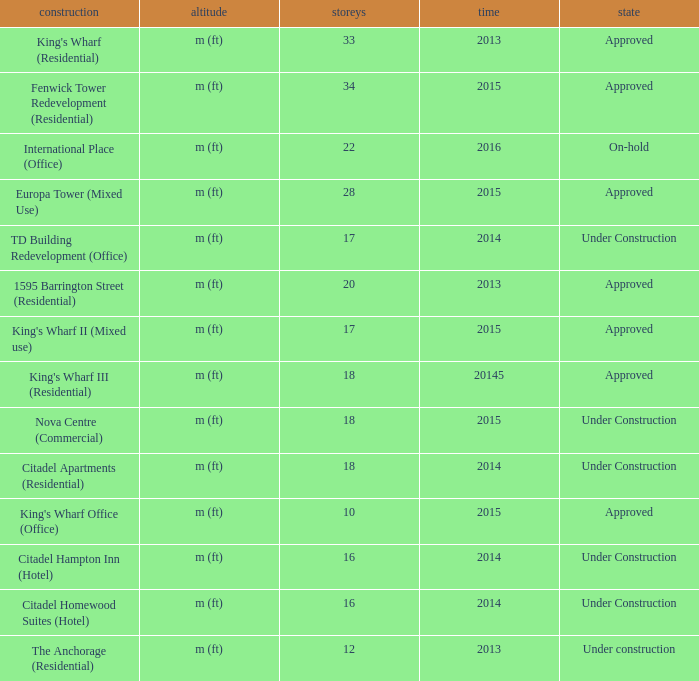What is the status of the building with less than 18 floors and later than 2013? Under Construction, Approved, Approved, Under Construction, Under Construction. 